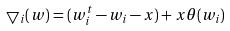<formula> <loc_0><loc_0><loc_500><loc_500>\bigtriangledown _ { i } ( w ) = ( w ^ { t } _ { i } - w _ { i } - x ) + x \theta ( w _ { i } )</formula> 